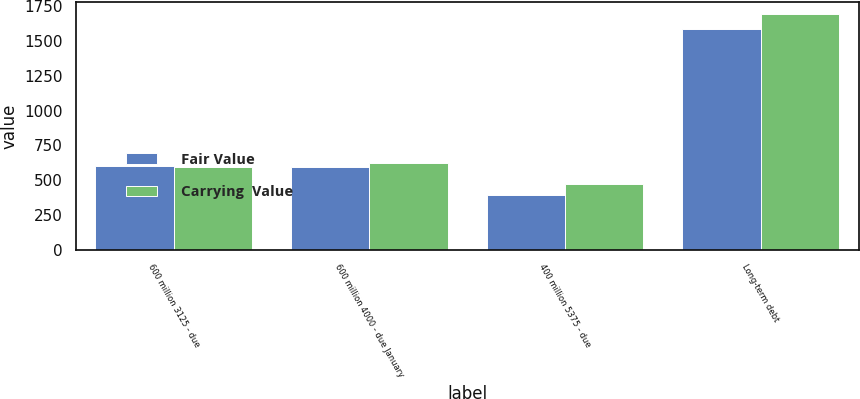<chart> <loc_0><loc_0><loc_500><loc_500><stacked_bar_chart><ecel><fcel>600 million 3125 - due<fcel>600 million 4000 - due January<fcel>400 million 5375 - due<fcel>Long-term debt<nl><fcel>Fair Value<fcel>599.6<fcel>596.2<fcel>393.5<fcel>1589.3<nl><fcel>Carrying  Value<fcel>596.8<fcel>625.9<fcel>473.1<fcel>1695.8<nl></chart> 